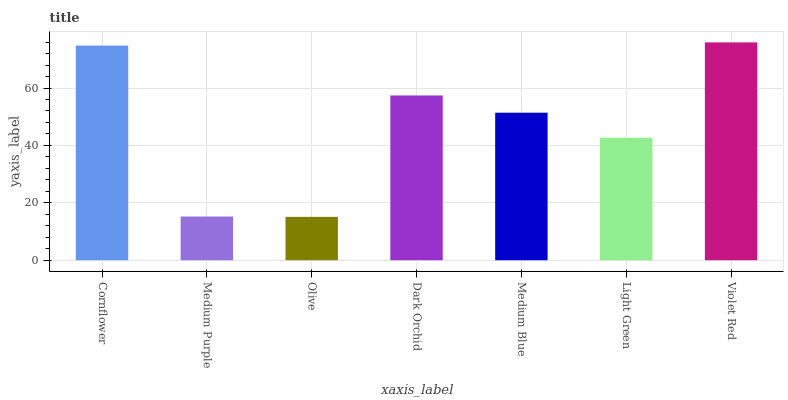Is Olive the minimum?
Answer yes or no. Yes. Is Violet Red the maximum?
Answer yes or no. Yes. Is Medium Purple the minimum?
Answer yes or no. No. Is Medium Purple the maximum?
Answer yes or no. No. Is Cornflower greater than Medium Purple?
Answer yes or no. Yes. Is Medium Purple less than Cornflower?
Answer yes or no. Yes. Is Medium Purple greater than Cornflower?
Answer yes or no. No. Is Cornflower less than Medium Purple?
Answer yes or no. No. Is Medium Blue the high median?
Answer yes or no. Yes. Is Medium Blue the low median?
Answer yes or no. Yes. Is Light Green the high median?
Answer yes or no. No. Is Olive the low median?
Answer yes or no. No. 